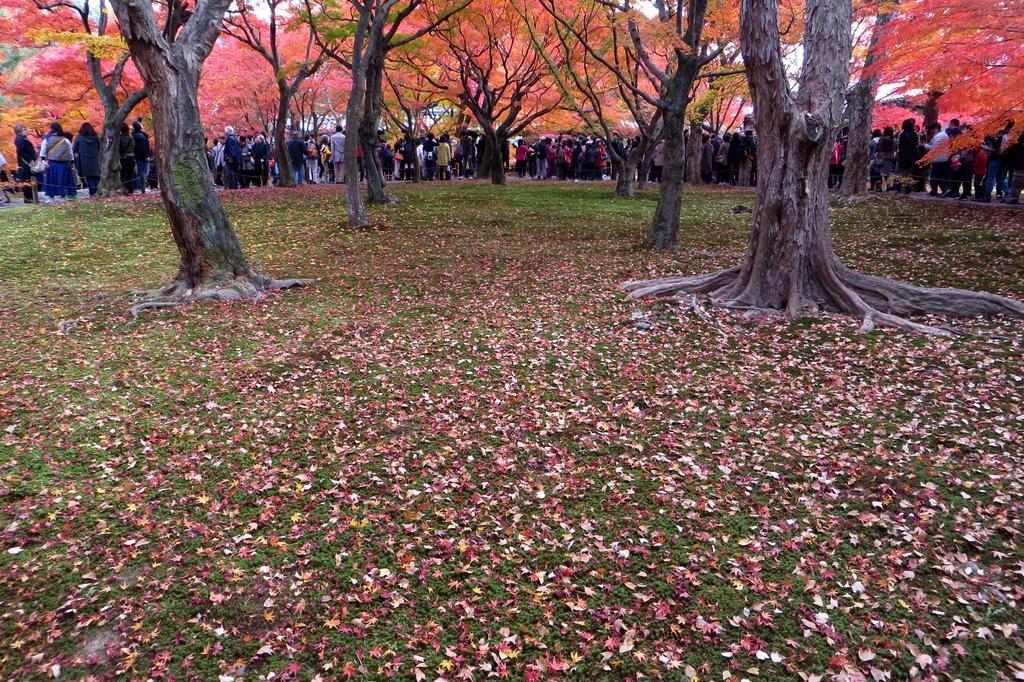How would you summarize this image in a sentence or two? There is grass on the ground on which, there are dry leaves and there are trees. In the background, there are persons in different color dresses standing on the road, there are trees and there is sky. 